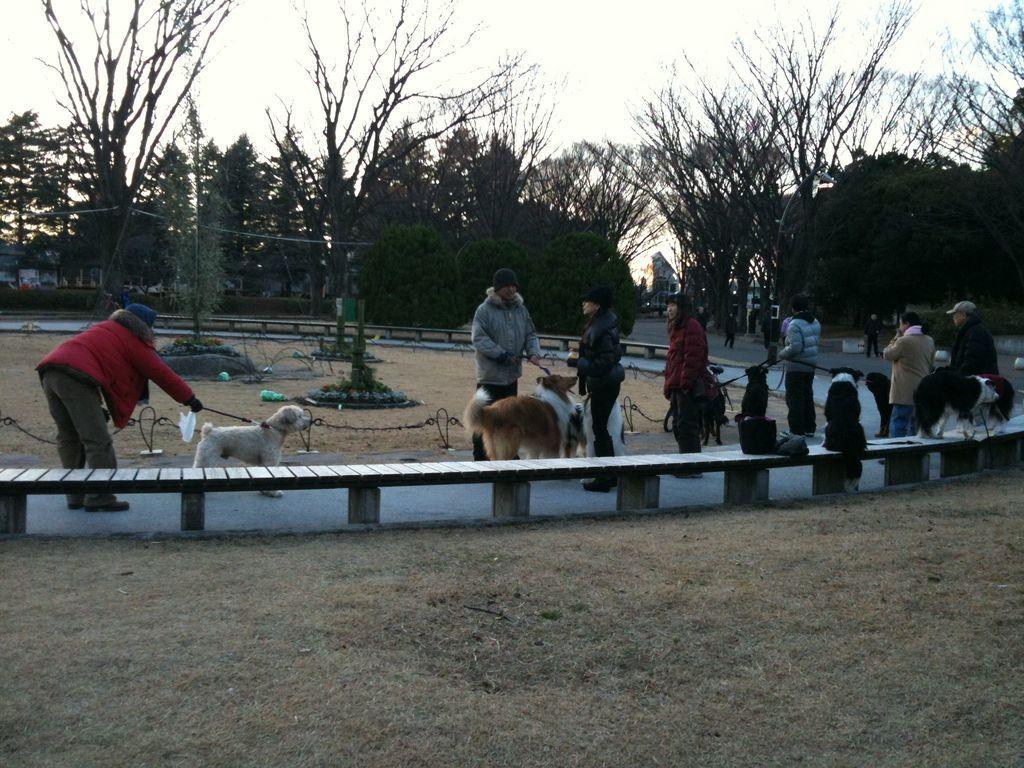Describe this image in one or two sentences. In this image I can see so many people standing on the ground holding dogs, also there is a bench and trees at back. 